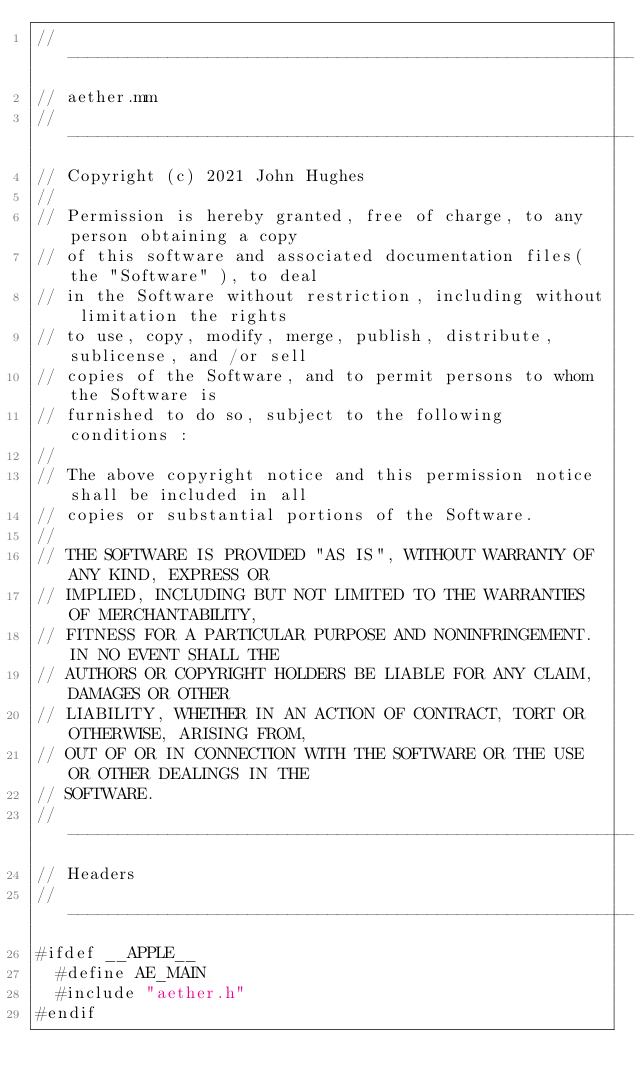<code> <loc_0><loc_0><loc_500><loc_500><_ObjectiveC_>//------------------------------------------------------------------------------
// aether.mm
//------------------------------------------------------------------------------
// Copyright (c) 2021 John Hughes
//
// Permission is hereby granted, free of charge, to any person obtaining a copy
// of this software and associated documentation files( the "Software" ), to deal
// in the Software without restriction, including without limitation the rights
// to use, copy, modify, merge, publish, distribute, sublicense, and /or sell
// copies of the Software, and to permit persons to whom the Software is
// furnished to do so, subject to the following conditions :
//
// The above copyright notice and this permission notice shall be included in all
// copies or substantial portions of the Software.
//
// THE SOFTWARE IS PROVIDED "AS IS", WITHOUT WARRANTY OF ANY KIND, EXPRESS OR
// IMPLIED, INCLUDING BUT NOT LIMITED TO THE WARRANTIES OF MERCHANTABILITY,
// FITNESS FOR A PARTICULAR PURPOSE AND NONINFRINGEMENT.IN NO EVENT SHALL THE
// AUTHORS OR COPYRIGHT HOLDERS BE LIABLE FOR ANY CLAIM, DAMAGES OR OTHER
// LIABILITY, WHETHER IN AN ACTION OF CONTRACT, TORT OR OTHERWISE, ARISING FROM,
// OUT OF OR IN CONNECTION WITH THE SOFTWARE OR THE USE OR OTHER DEALINGS IN THE
// SOFTWARE.
//------------------------------------------------------------------------------
// Headers
//------------------------------------------------------------------------------
#ifdef __APPLE__
  #define AE_MAIN
  #include "aether.h"
#endif
</code> 